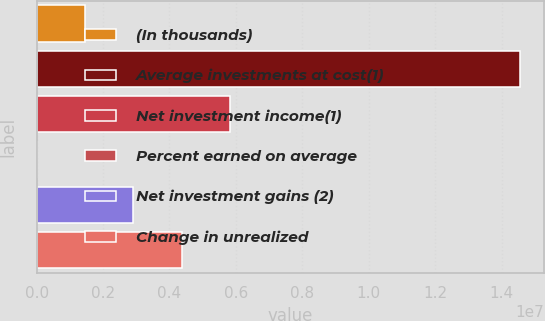<chart> <loc_0><loc_0><loc_500><loc_500><bar_chart><fcel>(In thousands)<fcel>Average investments at cost(1)<fcel>Net investment income(1)<fcel>Percent earned on average<fcel>Net investment gains (2)<fcel>Change in unrealized<nl><fcel>1.45454e+06<fcel>1.45454e+07<fcel>5.81815e+06<fcel>4<fcel>2.90908e+06<fcel>4.36361e+06<nl></chart> 